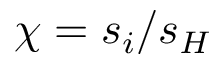<formula> <loc_0><loc_0><loc_500><loc_500>\chi = s _ { i } / s _ { H }</formula> 